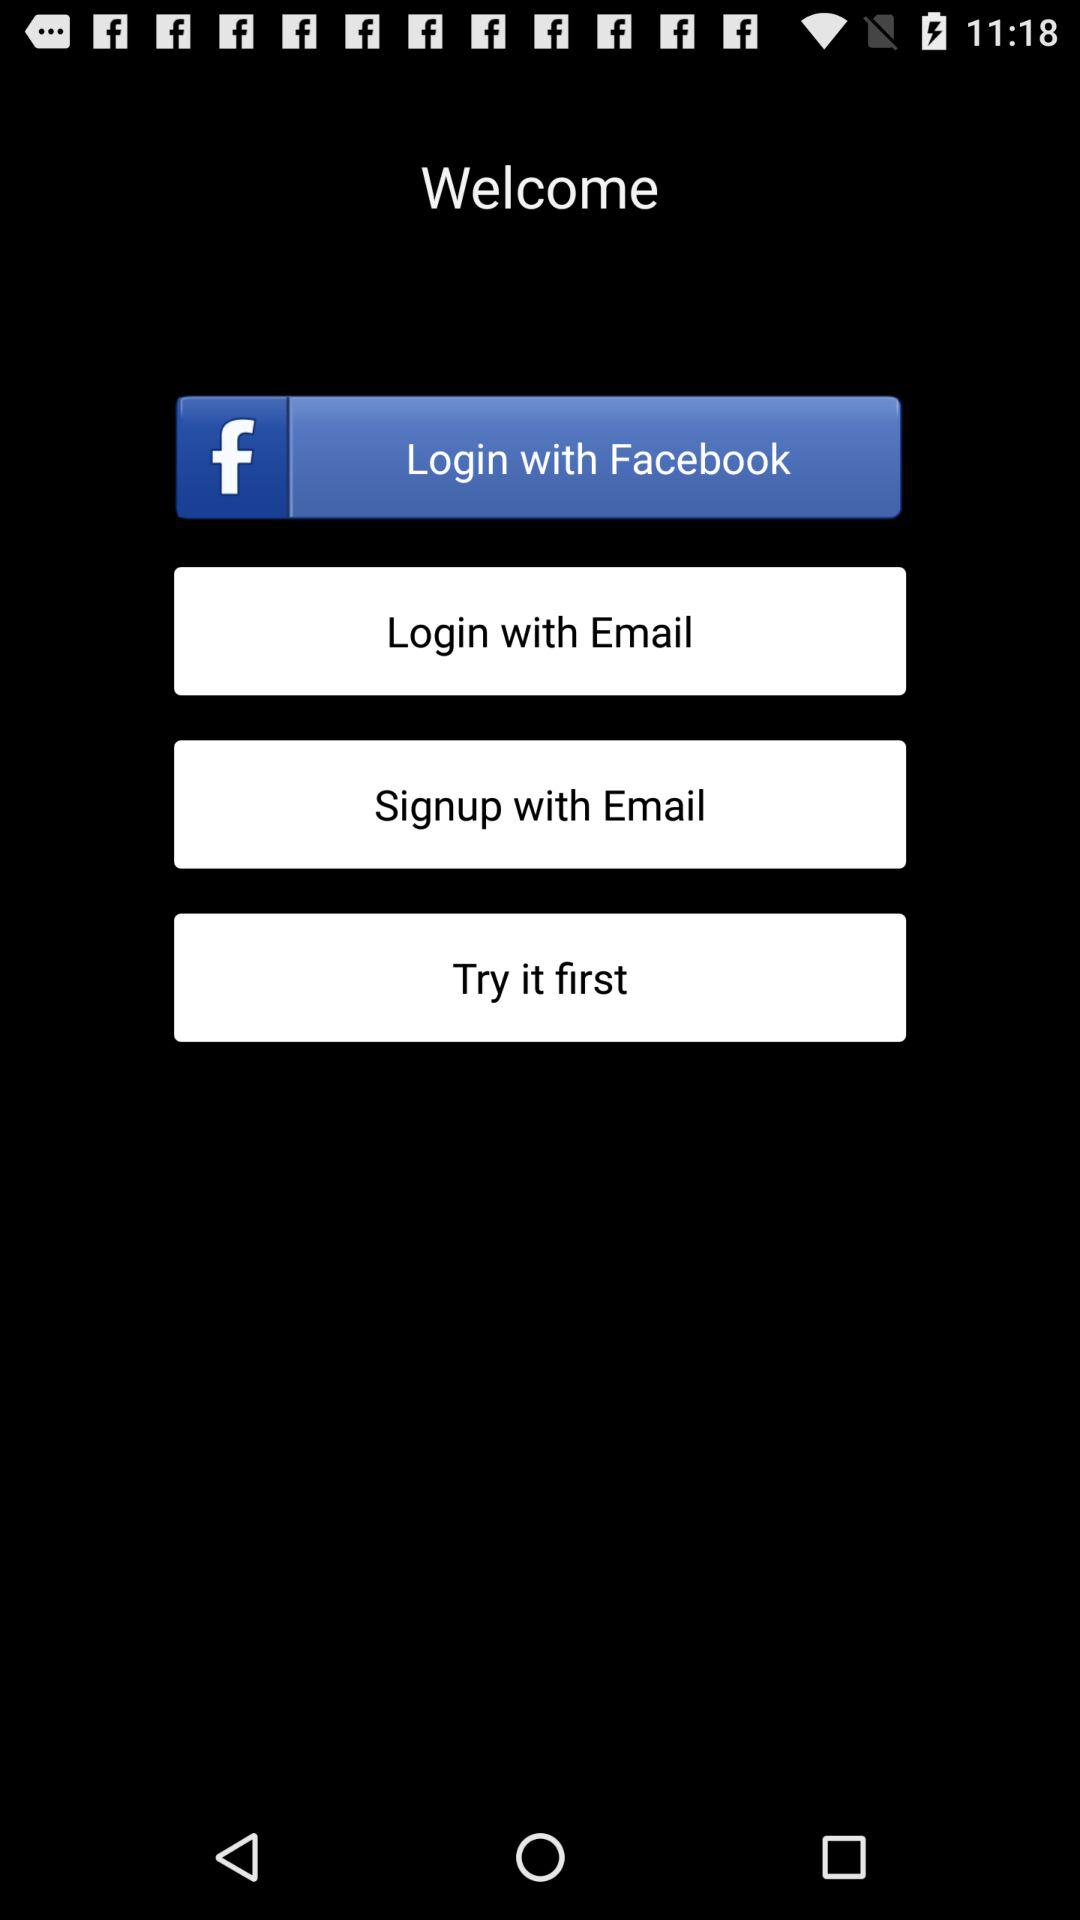Which login option is selected?
When the provided information is insufficient, respond with <no answer>. <no answer> 